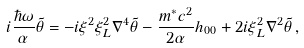Convert formula to latex. <formula><loc_0><loc_0><loc_500><loc_500>i \frac { \hbar { \omega } } { \alpha } \tilde { \theta } = - i \xi ^ { 2 } \xi _ { L } ^ { 2 } \nabla ^ { 4 } \tilde { \theta } - \frac { m ^ { \ast } c ^ { 2 } } { 2 \alpha } h _ { 0 0 } + 2 i \xi _ { L } ^ { 2 } \nabla ^ { 2 } \tilde { \theta } \, ,</formula> 